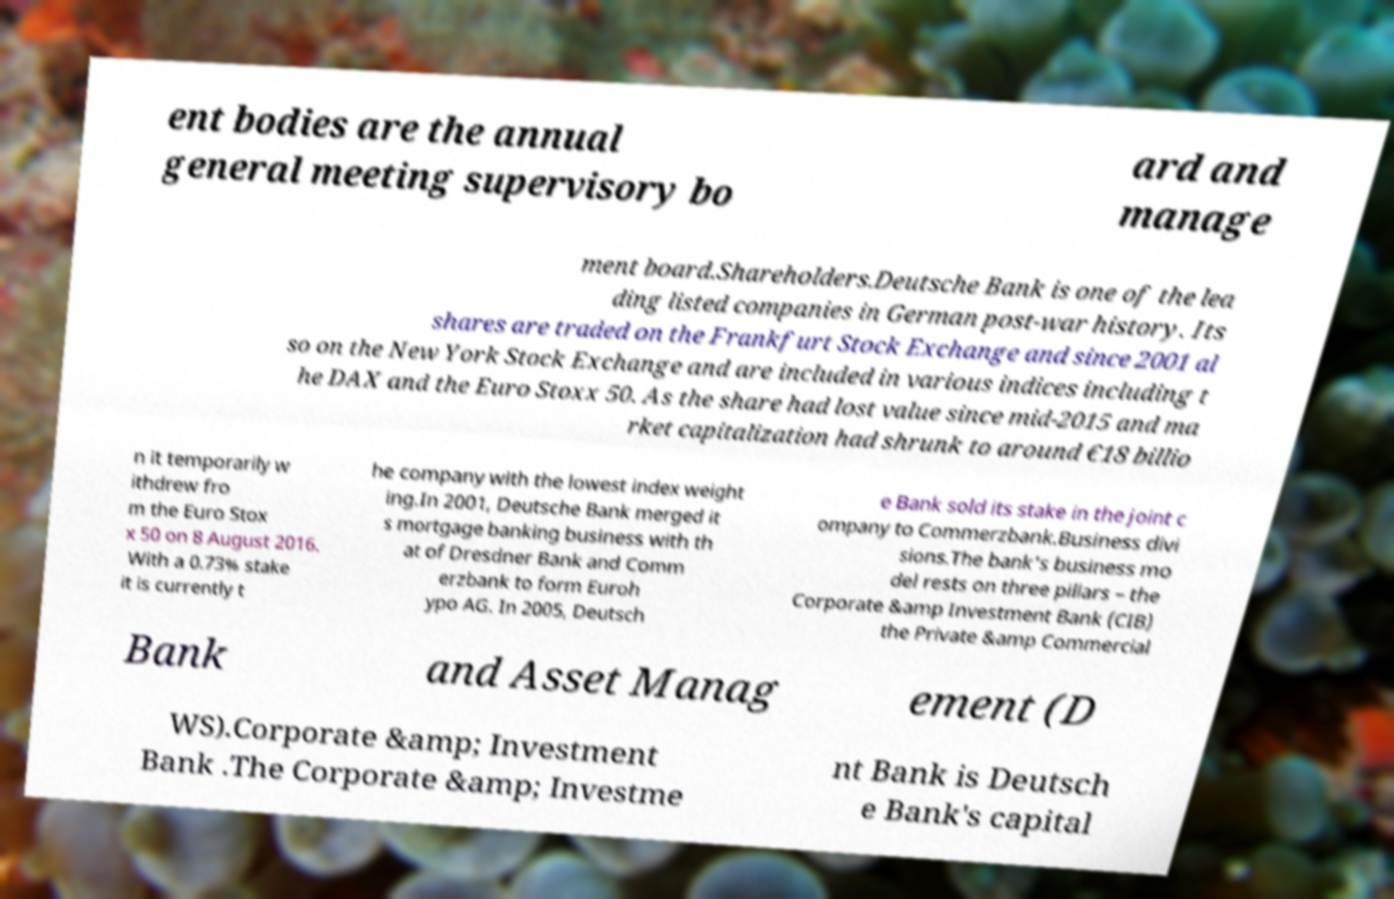Could you extract and type out the text from this image? ent bodies are the annual general meeting supervisory bo ard and manage ment board.Shareholders.Deutsche Bank is one of the lea ding listed companies in German post-war history. Its shares are traded on the Frankfurt Stock Exchange and since 2001 al so on the New York Stock Exchange and are included in various indices including t he DAX and the Euro Stoxx 50. As the share had lost value since mid-2015 and ma rket capitalization had shrunk to around €18 billio n it temporarily w ithdrew fro m the Euro Stox x 50 on 8 August 2016. With a 0.73% stake it is currently t he company with the lowest index weight ing.In 2001, Deutsche Bank merged it s mortgage banking business with th at of Dresdner Bank and Comm erzbank to form Euroh ypo AG. In 2005, Deutsch e Bank sold its stake in the joint c ompany to Commerzbank.Business divi sions.The bank's business mo del rests on three pillars – the Corporate &amp Investment Bank (CIB) the Private &amp Commercial Bank and Asset Manag ement (D WS).Corporate &amp; Investment Bank .The Corporate &amp; Investme nt Bank is Deutsch e Bank's capital 